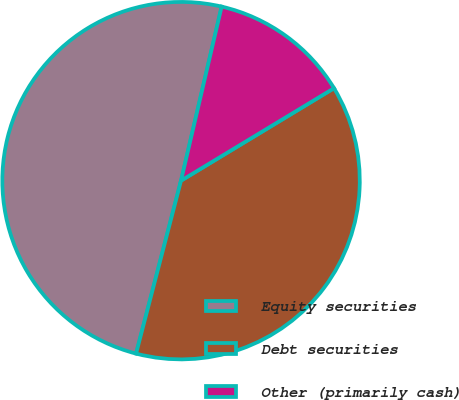<chart> <loc_0><loc_0><loc_500><loc_500><pie_chart><fcel>Equity securities<fcel>Debt securities<fcel>Other (primarily cash)<nl><fcel>49.6%<fcel>37.7%<fcel>12.7%<nl></chart> 